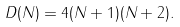<formula> <loc_0><loc_0><loc_500><loc_500>D ( N ) = 4 ( N + 1 ) ( N + 2 ) .</formula> 